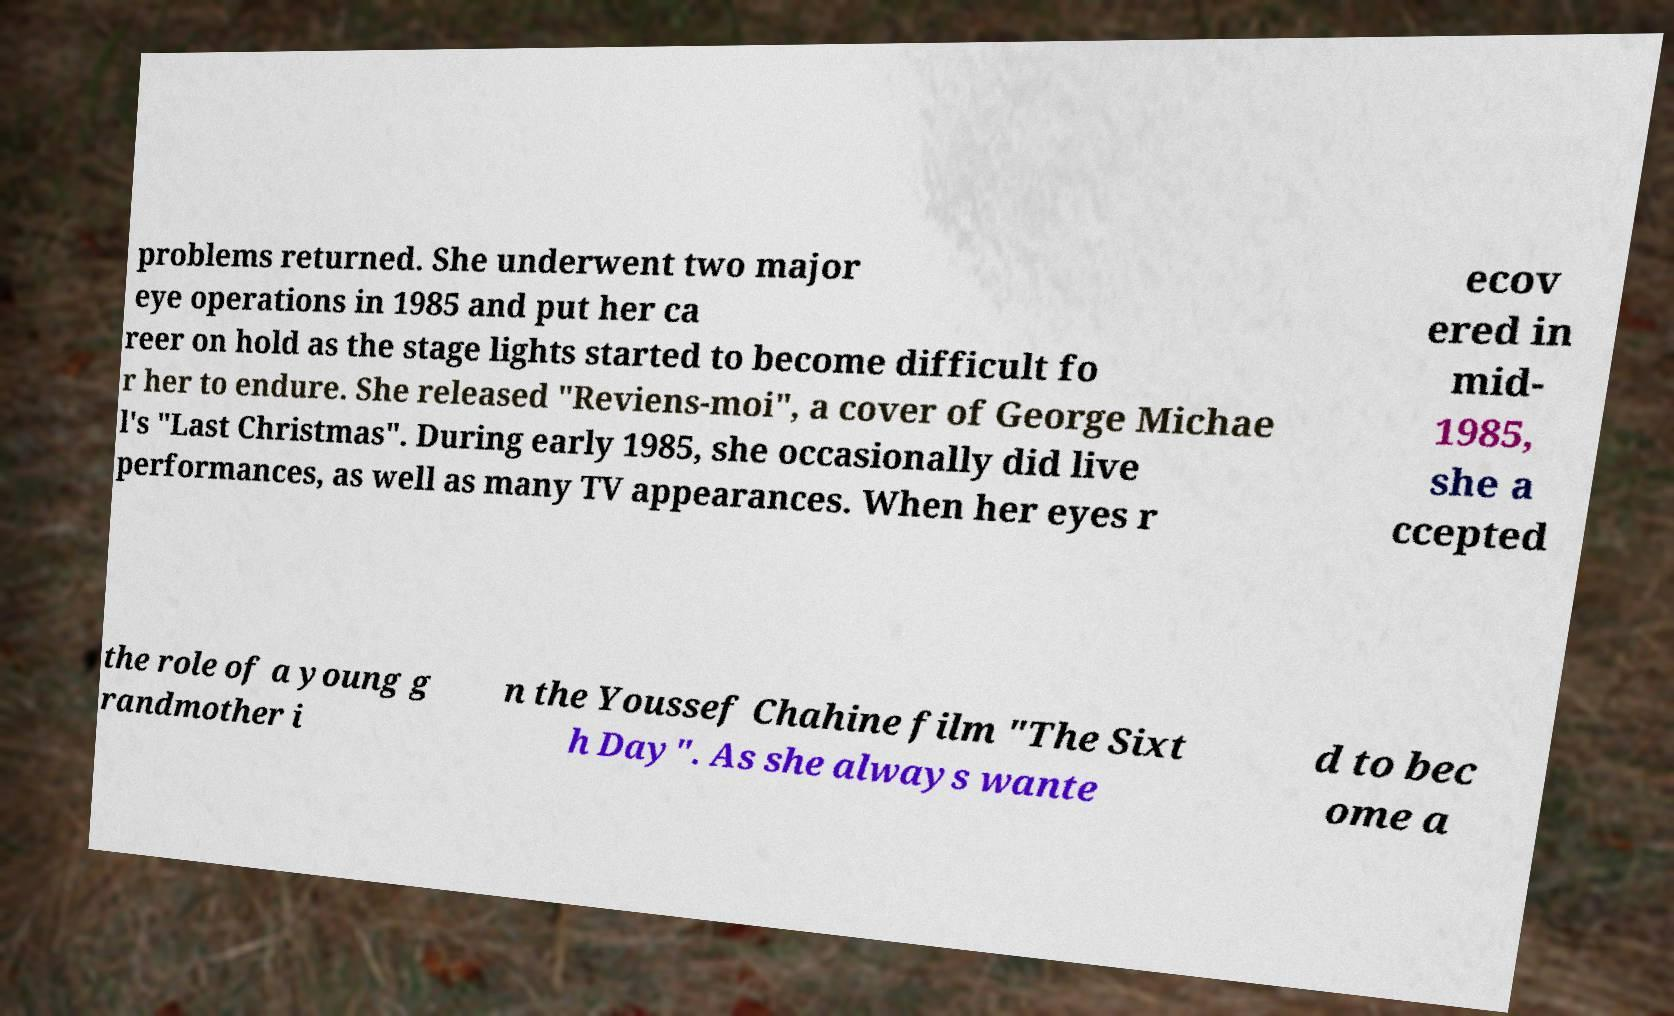What messages or text are displayed in this image? I need them in a readable, typed format. problems returned. She underwent two major eye operations in 1985 and put her ca reer on hold as the stage lights started to become difficult fo r her to endure. She released "Reviens-moi", a cover of George Michae l's "Last Christmas". During early 1985, she occasionally did live performances, as well as many TV appearances. When her eyes r ecov ered in mid- 1985, she a ccepted the role of a young g randmother i n the Youssef Chahine film "The Sixt h Day". As she always wante d to bec ome a 